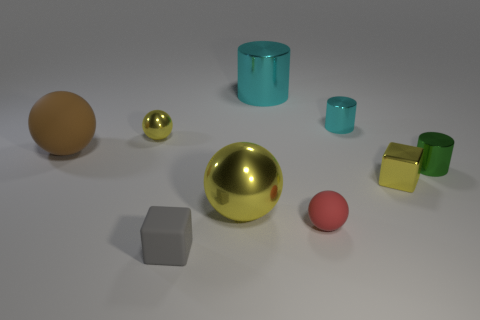There is another ball that is the same color as the small metal ball; what is its size?
Provide a short and direct response. Large. How many small balls have the same color as the small metal block?
Provide a short and direct response. 1. There is a metallic cylinder that is both on the left side of the green thing and on the right side of the red rubber sphere; what is its color?
Provide a short and direct response. Cyan. What number of large red objects have the same material as the tiny green thing?
Your answer should be very brief. 0. How many things are there?
Your answer should be compact. 9. Does the red thing have the same size as the yellow ball in front of the brown ball?
Your answer should be very brief. No. What material is the cube in front of the yellow metallic thing right of the red rubber sphere?
Provide a short and direct response. Rubber. What is the size of the yellow sphere behind the rubber ball behind the matte ball in front of the small yellow shiny block?
Give a very brief answer. Small. Do the small green object and the small yellow object behind the brown matte object have the same shape?
Your answer should be compact. No. What is the small cyan object made of?
Your answer should be compact. Metal. 